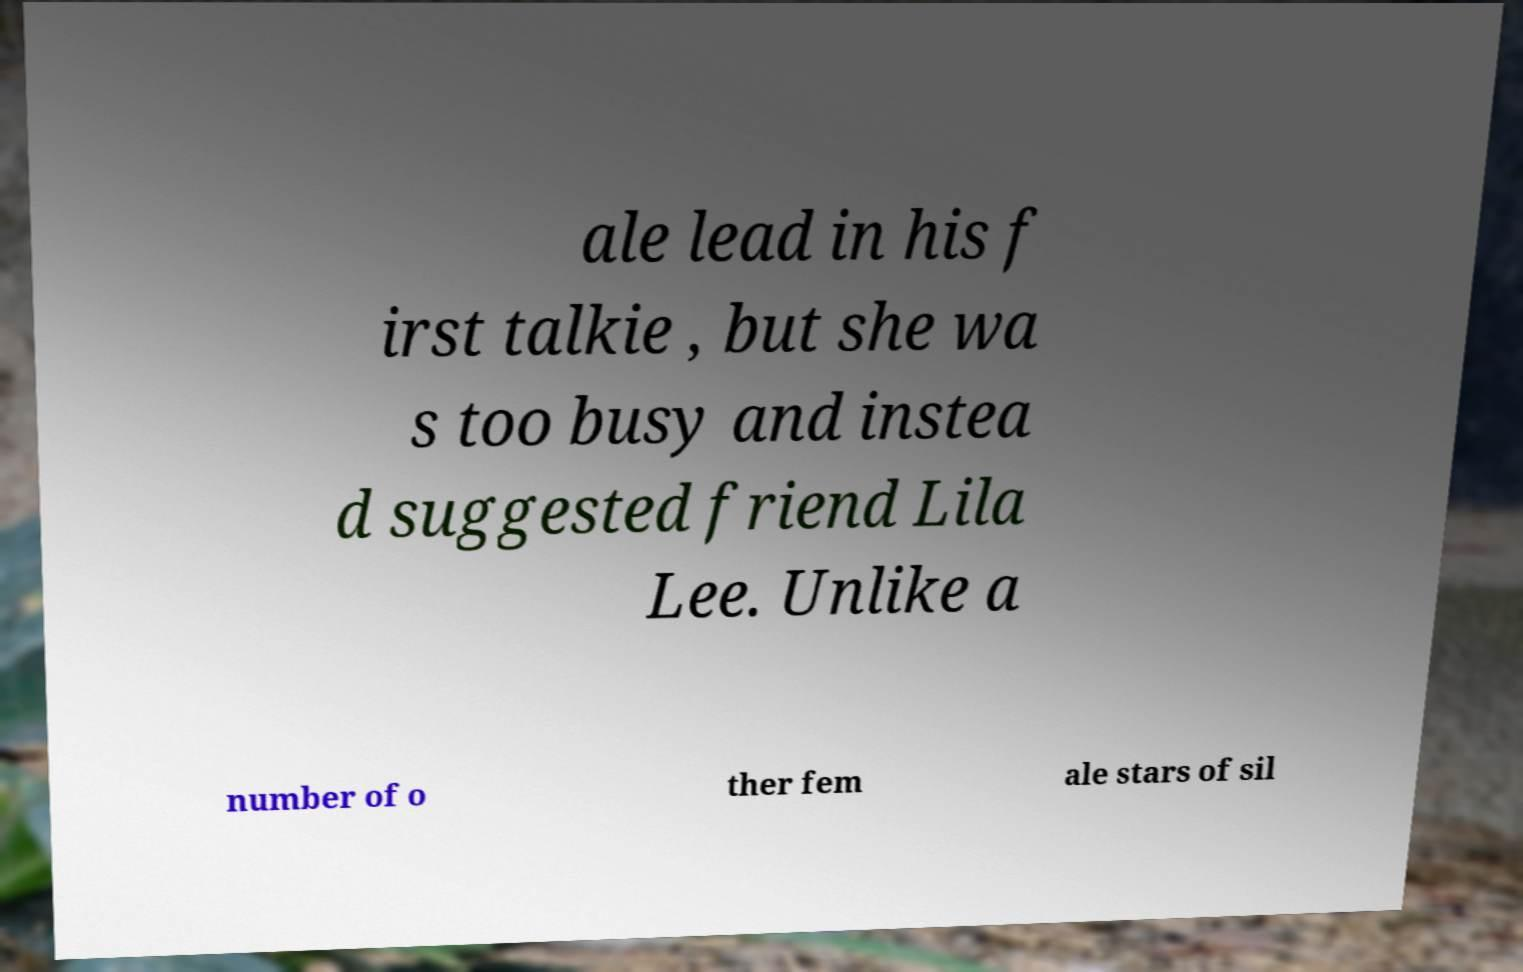Can you accurately transcribe the text from the provided image for me? ale lead in his f irst talkie , but she wa s too busy and instea d suggested friend Lila Lee. Unlike a number of o ther fem ale stars of sil 